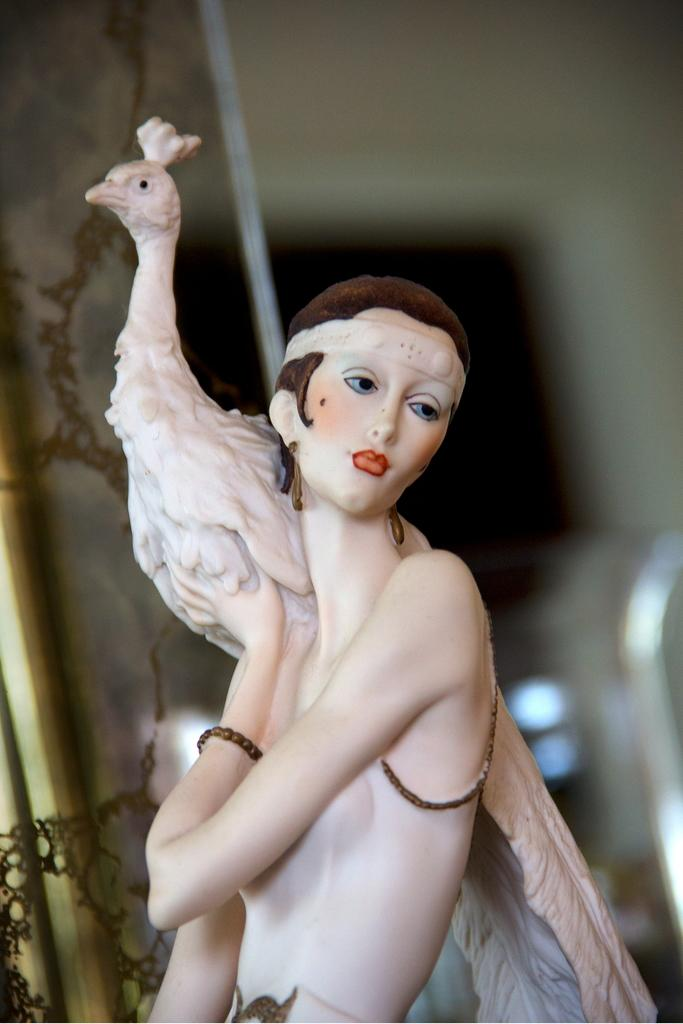What is the main subject of the image? There is a statue of a person in the image. What other living creature is present in the image? There is a peacock in the image. Can you describe the background of the image? The background is blurry, and there are objects visible. What type of argument is the peacock having with the statue in the image? There is no argument present in the image; it features a statue of a person and a peacock. What color is the silver animal in the image? There is no silver animal present in the image. 